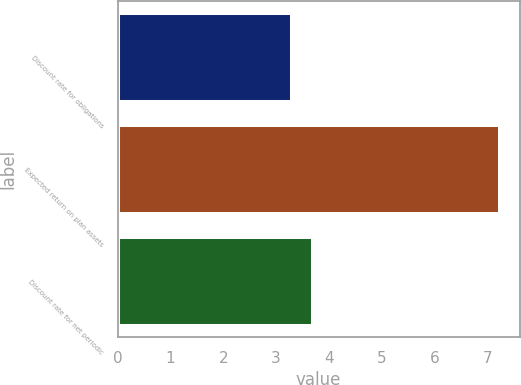Convert chart. <chart><loc_0><loc_0><loc_500><loc_500><bar_chart><fcel>Discount rate for obligations<fcel>Expected return on plan assets<fcel>Discount rate for net periodic<nl><fcel>3.3<fcel>7.25<fcel>3.69<nl></chart> 